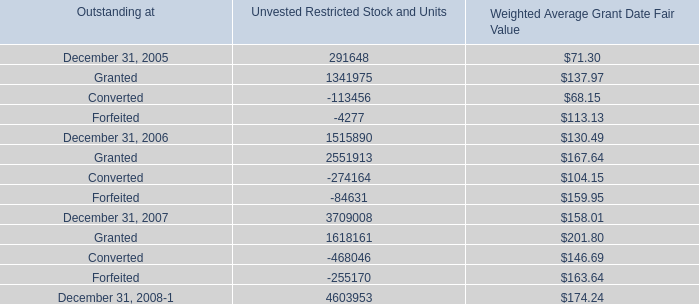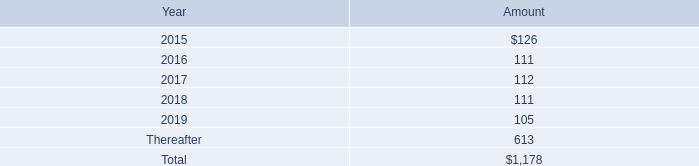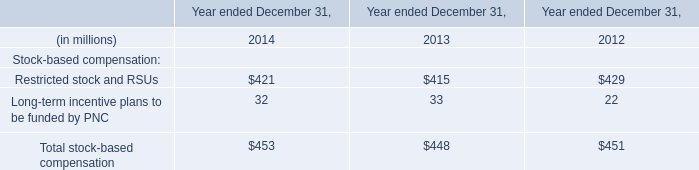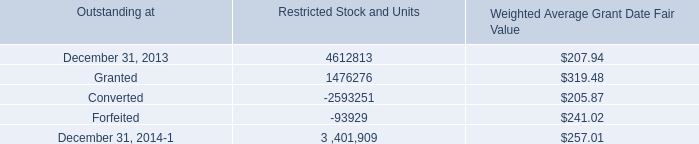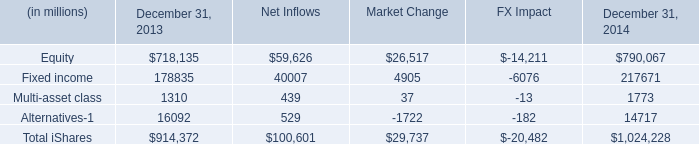what is the growth rate in rent expense and certain office equipment expense from 2012 to 2013? 
Computations: ((137 - 133) / 133)
Answer: 0.03008. 